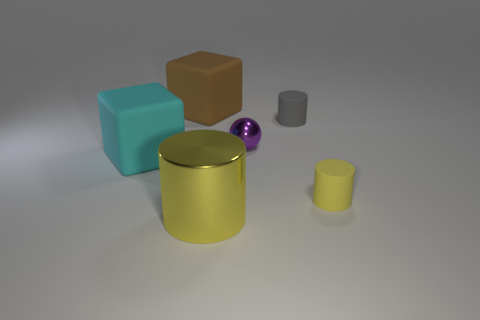How would you describe the layout of the objects in this image? The arrangement of the objects presents a balanced composition on a flat surface. The larger cylindrical yellow object is central and front-facing, drawing immediate attention. Flanking it are two blocks to the right—a teal cube and a brown cube—and to the left, we see a small purple sphere resting against the yellow cylinder. To the far left, a smaller gray cylinder echoes the shape of the bigger yellow one, providing visual harmony. 